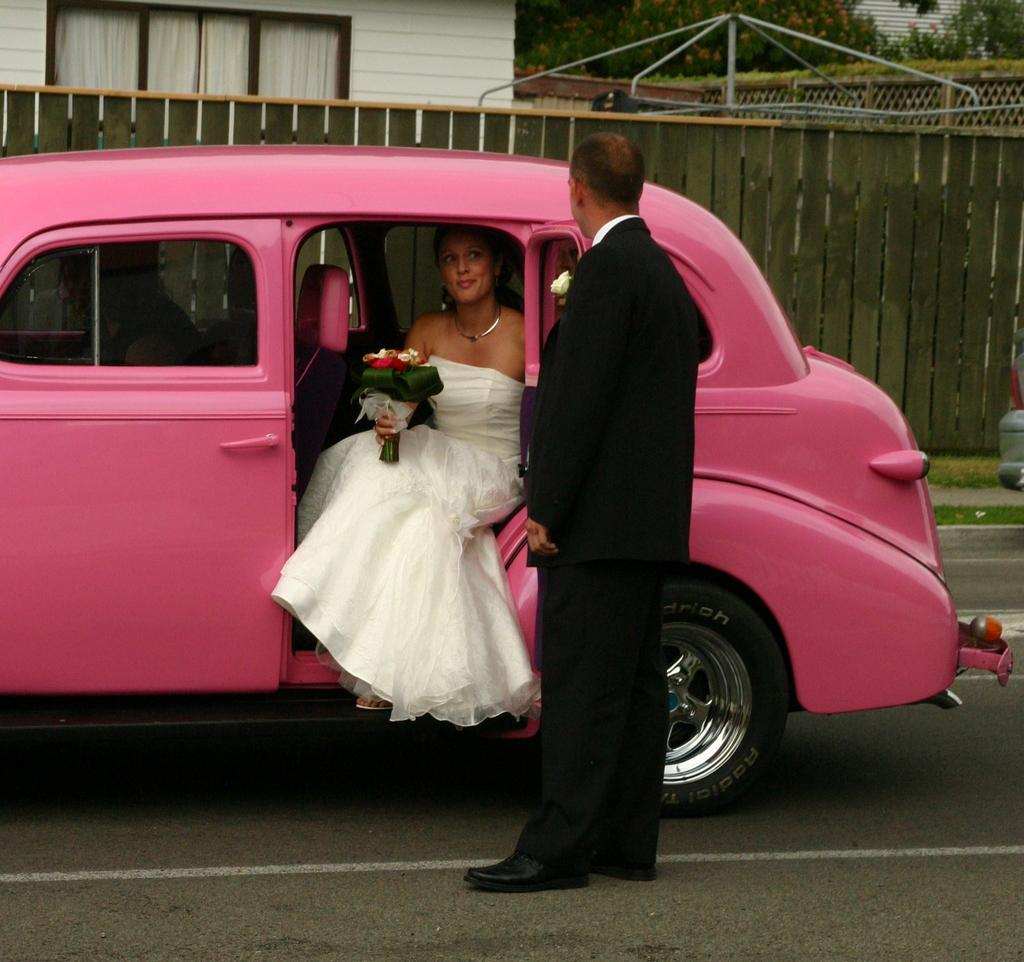What color is the car in the image? The car in the image is pink. Who is inside the car? A lady is inside the car, wearing a white gown. What is the lady holding in her hand? The lady is holding a bouquet in her hand. Who is standing outside the car? There is a guy standing outside the car. What type of detail can be seen on the car's exterior in the image? There is no specific detail mentioned on the car's exterior in the provided facts, so it cannot be determined from the image. 